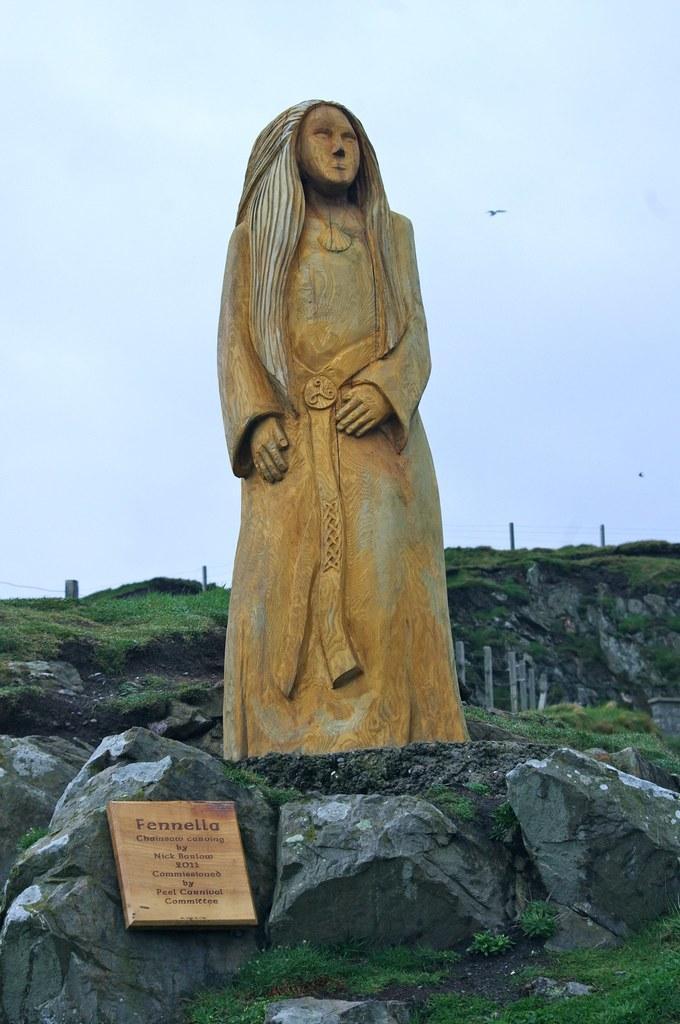Can you describe this image briefly? In the image we can see there is a statue of a person standing on the rock and there is a grid on which it's written "Fenella". 